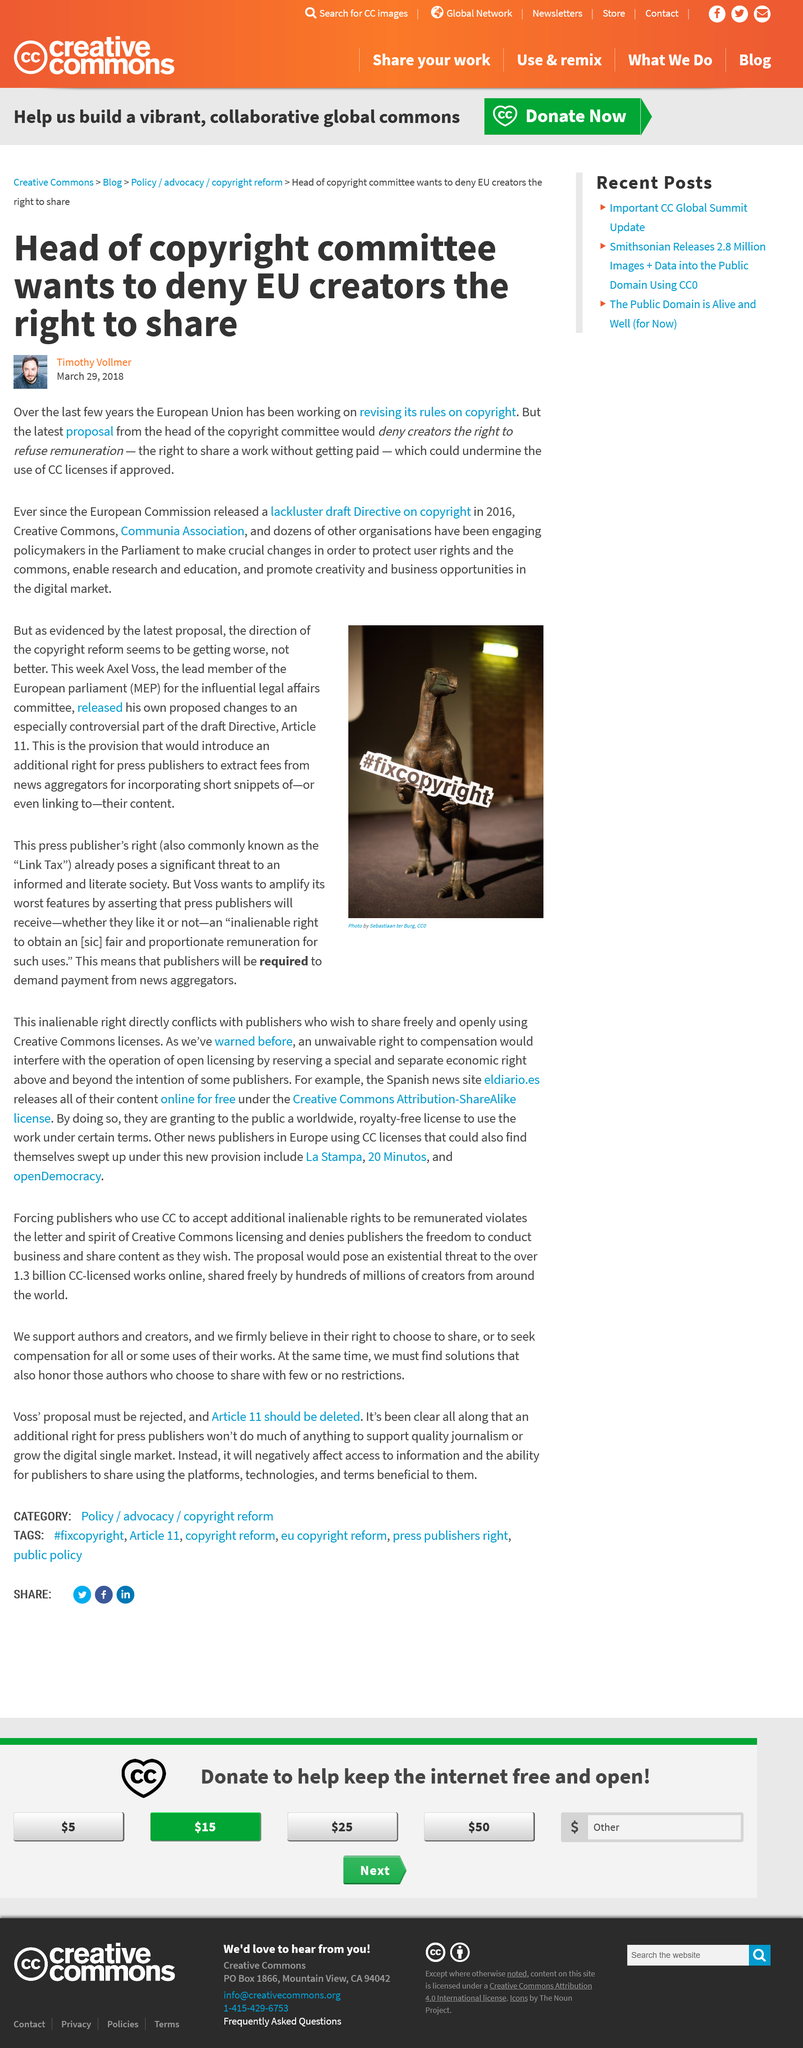Draw attention to some important aspects in this diagram. The head of the copyright committee is seeking to deny creators their right to share their work. The European Union has been working on revising its copyright rules for several years. The article titled "Head of copyright committee wants to deny EU creators the right to share" was published on March 29, 2018. 